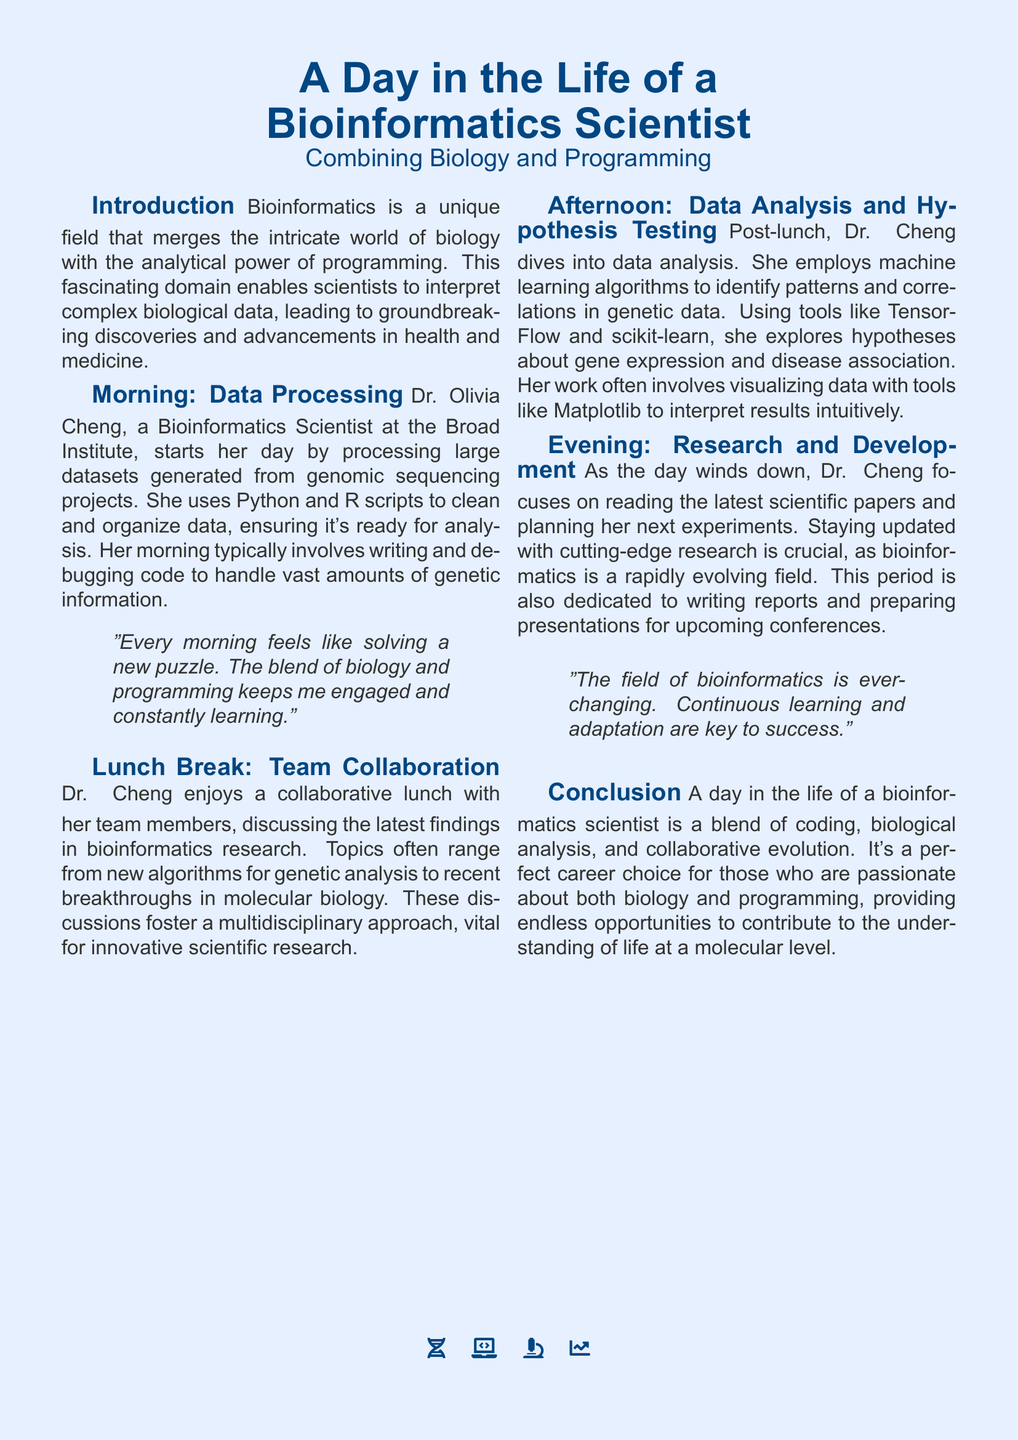What is the name of the bioinformatics scientist featured? The document introduces Dr. Olivia Cheng as the bioinformatics scientist in focus.
Answer: Dr. Olivia Cheng What programming languages does Dr. Cheng use? The document mentions that she uses Python and R for data processing.
Answer: Python and R What is a primary task of Dr. Cheng during her morning? The morning activities involve processing large datasets from genomic sequencing projects.
Answer: Processing datasets Which machine learning libraries does she employ in the afternoon? The document lists TensorFlow and scikit-learn as the tools she uses for analysis.
Answer: TensorFlow and scikit-learn What is the main focus of Dr. Cheng's evening work? Dr. Cheng spends her evening reading scientific papers and planning experiments.
Answer: Reading and planning Why is collaboration emphasized during lunch? The document mentions that discussing findings fosters a multidisciplinary approach, essential for innovation.
Answer: Multidisciplinary approach What does Dr. Cheng visualize data with? The document specifies that she uses Matplotlib for data visualization.
Answer: Matplotlib What does Dr. Cheng believe is crucial in bioinformatics? She indicates that continuous learning and adaptation are key in this ever-changing field.
Answer: Continuous learning What kind of discoveries does bioinformatics lead to? The introduction states that bioinformatics leads to groundbreaking discoveries and advancements in health and medicine.
Answer: Groundbreaking discoveries 